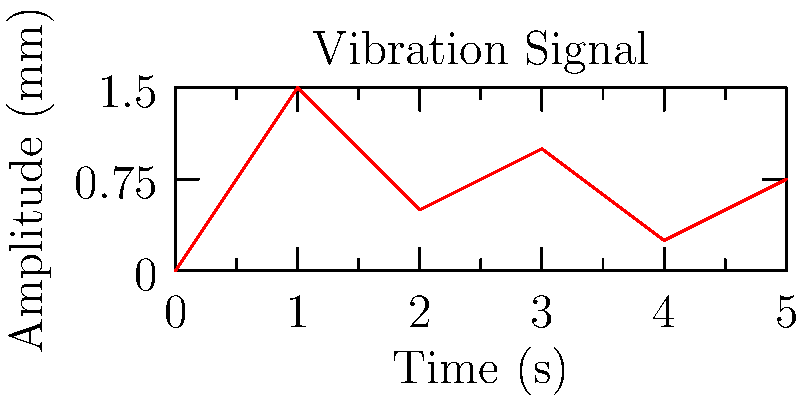A pharmaceutical company is using a centrifuge for sample preparation in drug discovery. The vibration analysis of the centrifuge yields the signal shown in the graph. What is the fundamental frequency of this vibration signal in Hz? To determine the fundamental frequency of the vibration signal, we need to follow these steps:

1. Identify the period of the signal:
   The period is the time it takes for one complete cycle of the waveform to occur.
   From the graph, we can see that one complete cycle occurs every 2 seconds.

2. Calculate the frequency:
   The frequency is the reciprocal of the period.
   
   $$f = \frac{1}{T}$$
   
   where $f$ is the frequency in Hz, and $T$ is the period in seconds.

3. Substitute the values:
   $$f = \frac{1}{2 \text{ s}} = 0.5 \text{ Hz}$$

Therefore, the fundamental frequency of the vibration signal is 0.5 Hz.
Answer: 0.5 Hz 